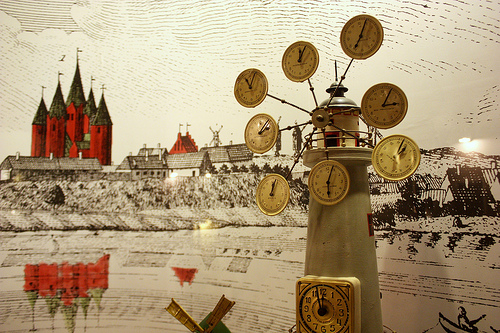<image>
Is there a clock on the tower? Yes. Looking at the image, I can see the clock is positioned on top of the tower, with the tower providing support. 